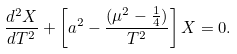<formula> <loc_0><loc_0><loc_500><loc_500>\frac { d ^ { 2 } X } { d T ^ { 2 } } + \left [ a ^ { 2 } - \frac { ( \mu ^ { 2 } - \frac { 1 } { 4 } ) } { T ^ { 2 } } \right ] X = 0 .</formula> 